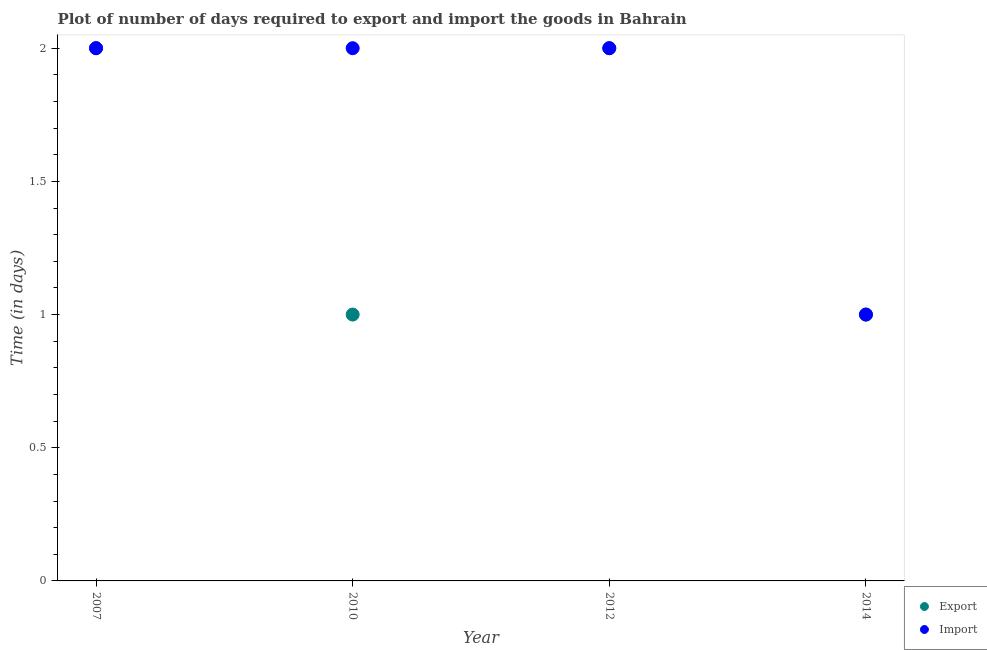How many different coloured dotlines are there?
Your answer should be very brief. 2. Is the number of dotlines equal to the number of legend labels?
Provide a succinct answer. Yes. What is the time required to import in 2010?
Your response must be concise. 2. Across all years, what is the maximum time required to export?
Offer a very short reply. 2. Across all years, what is the minimum time required to import?
Provide a short and direct response. 1. What is the difference between the time required to export in 2014 and the time required to import in 2012?
Your answer should be compact. -1. What is the average time required to import per year?
Your answer should be very brief. 1.75. In the year 2012, what is the difference between the time required to import and time required to export?
Provide a succinct answer. 0. In how many years, is the time required to import greater than 1.4 days?
Your response must be concise. 3. What is the ratio of the time required to export in 2010 to that in 2014?
Ensure brevity in your answer.  1. Is the time required to import in 2010 less than that in 2012?
Ensure brevity in your answer.  No. Is the difference between the time required to export in 2007 and 2012 greater than the difference between the time required to import in 2007 and 2012?
Offer a terse response. No. What is the difference between the highest and the second highest time required to export?
Your response must be concise. 0. What is the difference between the highest and the lowest time required to import?
Provide a succinct answer. 1. Is the sum of the time required to import in 2007 and 2010 greater than the maximum time required to export across all years?
Your answer should be very brief. Yes. How many dotlines are there?
Keep it short and to the point. 2. What is the difference between two consecutive major ticks on the Y-axis?
Provide a succinct answer. 0.5. Are the values on the major ticks of Y-axis written in scientific E-notation?
Offer a terse response. No. Does the graph contain grids?
Offer a terse response. No. Where does the legend appear in the graph?
Your answer should be very brief. Bottom right. How many legend labels are there?
Give a very brief answer. 2. What is the title of the graph?
Offer a terse response. Plot of number of days required to export and import the goods in Bahrain. Does "Register a property" appear as one of the legend labels in the graph?
Ensure brevity in your answer.  No. What is the label or title of the X-axis?
Offer a terse response. Year. What is the label or title of the Y-axis?
Provide a succinct answer. Time (in days). What is the Time (in days) in Import in 2014?
Your response must be concise. 1. Across all years, what is the maximum Time (in days) in Import?
Make the answer very short. 2. Across all years, what is the minimum Time (in days) of Export?
Your answer should be very brief. 1. Across all years, what is the minimum Time (in days) in Import?
Provide a succinct answer. 1. What is the total Time (in days) of Import in the graph?
Offer a terse response. 7. What is the difference between the Time (in days) of Import in 2007 and that in 2012?
Give a very brief answer. 0. What is the difference between the Time (in days) in Export in 2007 and that in 2014?
Ensure brevity in your answer.  1. What is the difference between the Time (in days) of Export in 2010 and that in 2012?
Give a very brief answer. -1. What is the difference between the Time (in days) in Export in 2010 and that in 2014?
Keep it short and to the point. 0. What is the difference between the Time (in days) in Export in 2012 and that in 2014?
Your answer should be compact. 1. What is the difference between the Time (in days) of Export in 2007 and the Time (in days) of Import in 2010?
Offer a very short reply. 0. What is the difference between the Time (in days) in Export in 2010 and the Time (in days) in Import in 2012?
Ensure brevity in your answer.  -1. What is the average Time (in days) in Export per year?
Provide a short and direct response. 1.5. In the year 2007, what is the difference between the Time (in days) in Export and Time (in days) in Import?
Offer a very short reply. 0. In the year 2010, what is the difference between the Time (in days) of Export and Time (in days) of Import?
Provide a succinct answer. -1. What is the ratio of the Time (in days) in Import in 2007 to that in 2012?
Make the answer very short. 1. What is the ratio of the Time (in days) of Export in 2007 to that in 2014?
Offer a terse response. 2. What is the ratio of the Time (in days) in Import in 2007 to that in 2014?
Offer a very short reply. 2. What is the ratio of the Time (in days) in Export in 2010 to that in 2012?
Offer a terse response. 0.5. What is the ratio of the Time (in days) in Export in 2010 to that in 2014?
Your answer should be compact. 1. What is the ratio of the Time (in days) of Import in 2010 to that in 2014?
Provide a short and direct response. 2. What is the difference between the highest and the second highest Time (in days) of Import?
Offer a very short reply. 0. 